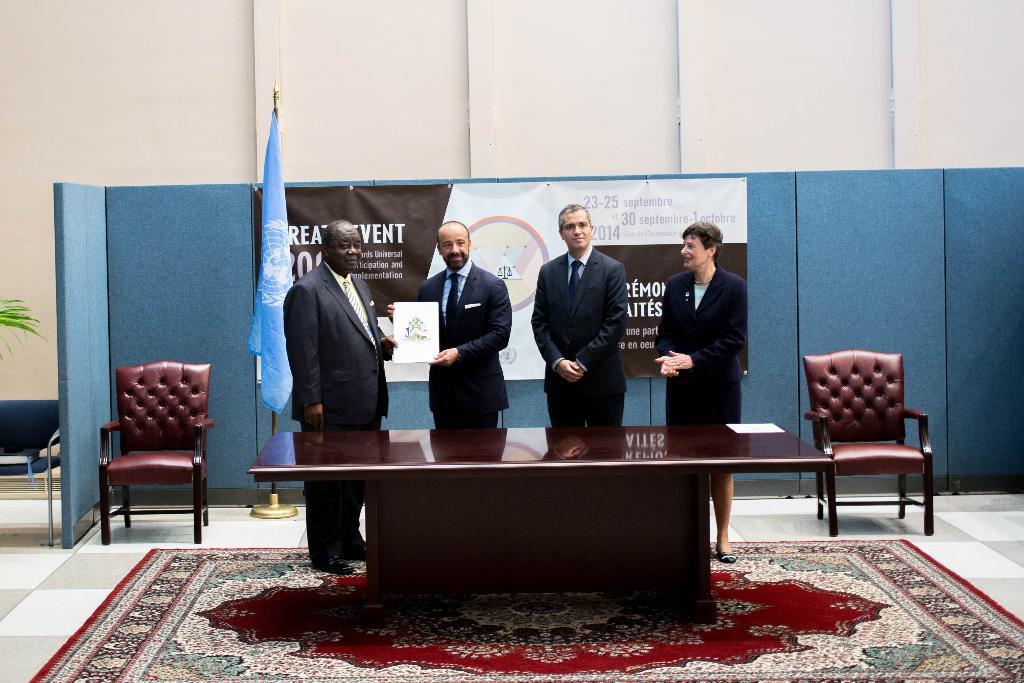Describe this image in one or two sentences. The two persons in the left is holding a certificate in there hands and there are two other persons standing beside them and there is a table in front of them and there are two chairs and a banner behind them. 